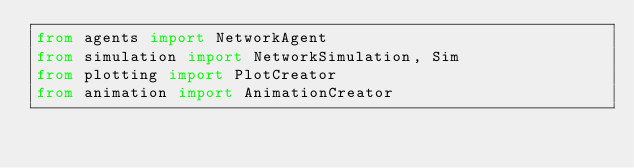Convert code to text. <code><loc_0><loc_0><loc_500><loc_500><_Python_>from agents import NetworkAgent
from simulation import NetworkSimulation, Sim
from plotting import PlotCreator
from animation import AnimationCreator</code> 